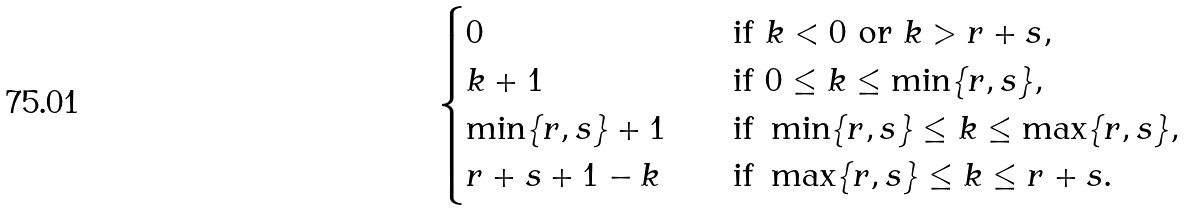<formula> <loc_0><loc_0><loc_500><loc_500>\begin{cases} 0 & \text {if } k < 0 \text { or } k > r + s , \\ k + 1 \quad & \text {if } 0 \leq k \leq \min \{ r , s \} , \\ \min \{ r , s \} + 1 \quad & \text {if } \min \{ r , s \} \leq k \leq \max \{ r , s \} , \\ r + s + 1 - k \quad & \text {if } \max \{ r , s \} \leq k \leq r + s . \end{cases}</formula> 